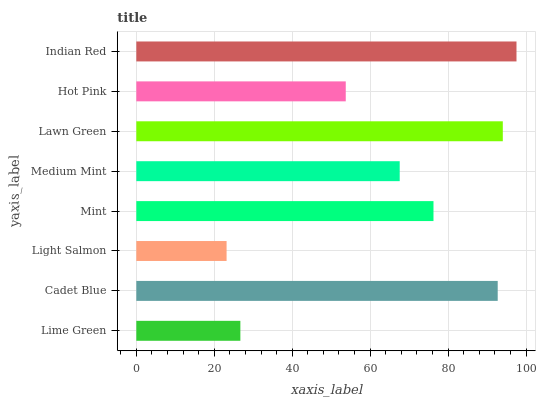Is Light Salmon the minimum?
Answer yes or no. Yes. Is Indian Red the maximum?
Answer yes or no. Yes. Is Cadet Blue the minimum?
Answer yes or no. No. Is Cadet Blue the maximum?
Answer yes or no. No. Is Cadet Blue greater than Lime Green?
Answer yes or no. Yes. Is Lime Green less than Cadet Blue?
Answer yes or no. Yes. Is Lime Green greater than Cadet Blue?
Answer yes or no. No. Is Cadet Blue less than Lime Green?
Answer yes or no. No. Is Mint the high median?
Answer yes or no. Yes. Is Medium Mint the low median?
Answer yes or no. Yes. Is Lime Green the high median?
Answer yes or no. No. Is Light Salmon the low median?
Answer yes or no. No. 